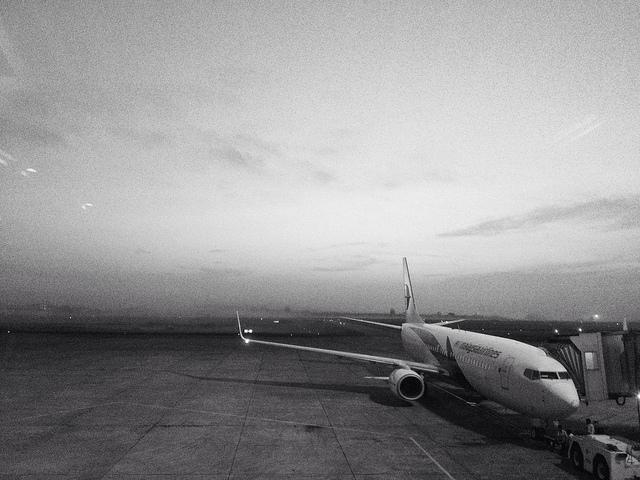What time is it on the image?

Choices:
A) morning
B) afternoon
C) night
D) noon night 